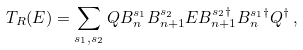<formula> <loc_0><loc_0><loc_500><loc_500>T _ { R } ( E ) = \sum _ { s _ { 1 } , s _ { 2 } } Q B ^ { s _ { 1 } } _ { n } B _ { n + 1 } ^ { s _ { 2 } } E B _ { n + 1 } ^ { s _ { 2 } \dagger } B ^ { s _ { 1 } \dagger } _ { n } Q ^ { \dagger } \, ,</formula> 